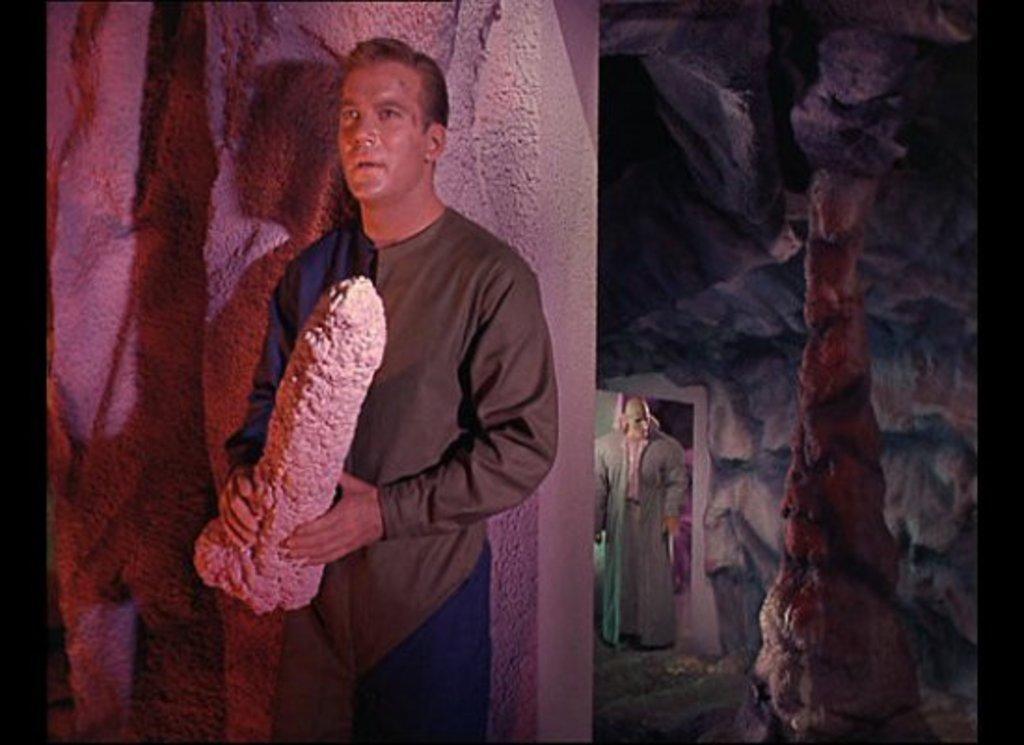Could you give a brief overview of what you see in this image? In this image I can see the person with the dress and holding an object. To the right I can see some setting and an another person with the costume. 